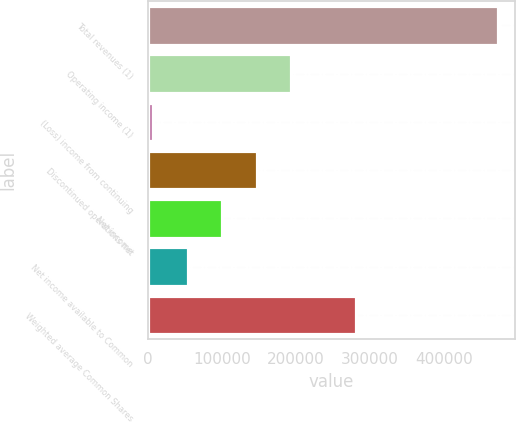<chart> <loc_0><loc_0><loc_500><loc_500><bar_chart><fcel>Total revenues (1)<fcel>Operating income (1)<fcel>(Loss) income from continuing<fcel>Discontinued operations net<fcel>Net income<fcel>Net income available to Common<fcel>Weighted average Common Shares<nl><fcel>472082<fcel>193193<fcel>7267<fcel>146712<fcel>100230<fcel>53748.5<fcel>280645<nl></chart> 